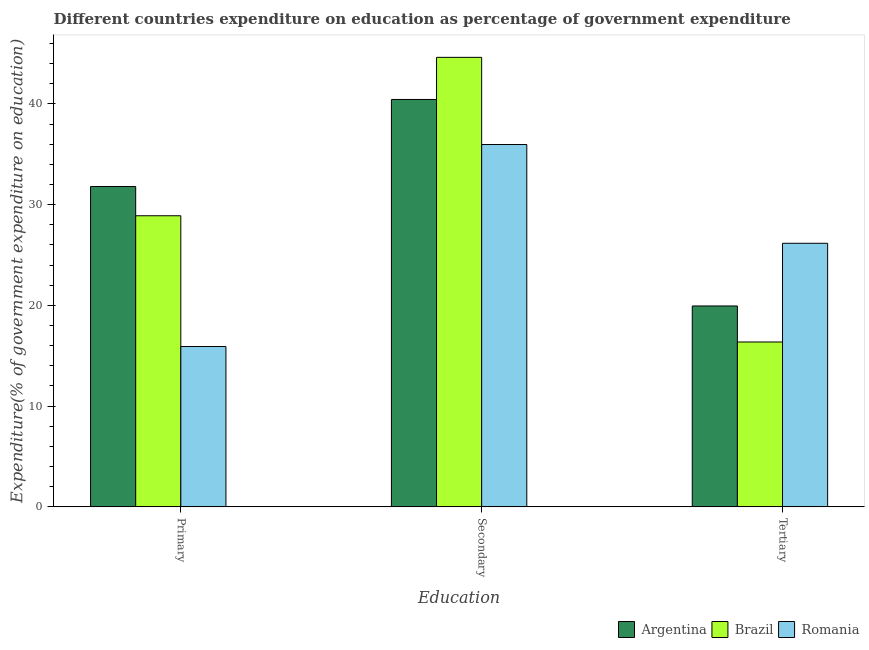How many different coloured bars are there?
Offer a very short reply. 3. How many groups of bars are there?
Ensure brevity in your answer.  3. Are the number of bars on each tick of the X-axis equal?
Your response must be concise. Yes. How many bars are there on the 2nd tick from the left?
Make the answer very short. 3. What is the label of the 1st group of bars from the left?
Ensure brevity in your answer.  Primary. What is the expenditure on tertiary education in Argentina?
Ensure brevity in your answer.  19.94. Across all countries, what is the maximum expenditure on tertiary education?
Give a very brief answer. 26.16. Across all countries, what is the minimum expenditure on tertiary education?
Ensure brevity in your answer.  16.37. In which country was the expenditure on tertiary education maximum?
Offer a very short reply. Romania. In which country was the expenditure on tertiary education minimum?
Provide a short and direct response. Brazil. What is the total expenditure on primary education in the graph?
Your answer should be compact. 76.61. What is the difference between the expenditure on primary education in Brazil and that in Romania?
Provide a short and direct response. 12.98. What is the difference between the expenditure on primary education in Brazil and the expenditure on secondary education in Romania?
Your answer should be compact. -7.07. What is the average expenditure on secondary education per country?
Your answer should be compact. 40.34. What is the difference between the expenditure on primary education and expenditure on tertiary education in Romania?
Keep it short and to the point. -10.25. In how many countries, is the expenditure on primary education greater than 2 %?
Your answer should be very brief. 3. What is the ratio of the expenditure on tertiary education in Brazil to that in Romania?
Your response must be concise. 0.63. What is the difference between the highest and the second highest expenditure on primary education?
Offer a very short reply. 2.9. What is the difference between the highest and the lowest expenditure on primary education?
Your answer should be compact. 15.88. In how many countries, is the expenditure on primary education greater than the average expenditure on primary education taken over all countries?
Ensure brevity in your answer.  2. What does the 1st bar from the left in Tertiary represents?
Provide a succinct answer. Argentina. What does the 1st bar from the right in Primary represents?
Your answer should be very brief. Romania. Is it the case that in every country, the sum of the expenditure on primary education and expenditure on secondary education is greater than the expenditure on tertiary education?
Provide a succinct answer. Yes. How many bars are there?
Your response must be concise. 9. Are all the bars in the graph horizontal?
Your answer should be compact. No. How many countries are there in the graph?
Make the answer very short. 3. What is the difference between two consecutive major ticks on the Y-axis?
Offer a very short reply. 10. Are the values on the major ticks of Y-axis written in scientific E-notation?
Your response must be concise. No. Does the graph contain grids?
Provide a short and direct response. No. How are the legend labels stacked?
Offer a terse response. Horizontal. What is the title of the graph?
Your response must be concise. Different countries expenditure on education as percentage of government expenditure. What is the label or title of the X-axis?
Provide a succinct answer. Education. What is the label or title of the Y-axis?
Make the answer very short. Expenditure(% of government expenditure on education). What is the Expenditure(% of government expenditure on education) of Argentina in Primary?
Your answer should be very brief. 31.8. What is the Expenditure(% of government expenditure on education) in Brazil in Primary?
Give a very brief answer. 28.89. What is the Expenditure(% of government expenditure on education) in Romania in Primary?
Keep it short and to the point. 15.92. What is the Expenditure(% of government expenditure on education) in Argentina in Secondary?
Provide a short and direct response. 40.44. What is the Expenditure(% of government expenditure on education) of Brazil in Secondary?
Your answer should be very brief. 44.62. What is the Expenditure(% of government expenditure on education) in Romania in Secondary?
Your answer should be very brief. 35.97. What is the Expenditure(% of government expenditure on education) in Argentina in Tertiary?
Your answer should be compact. 19.94. What is the Expenditure(% of government expenditure on education) in Brazil in Tertiary?
Make the answer very short. 16.37. What is the Expenditure(% of government expenditure on education) of Romania in Tertiary?
Provide a short and direct response. 26.16. Across all Education, what is the maximum Expenditure(% of government expenditure on education) of Argentina?
Your response must be concise. 40.44. Across all Education, what is the maximum Expenditure(% of government expenditure on education) of Brazil?
Ensure brevity in your answer.  44.62. Across all Education, what is the maximum Expenditure(% of government expenditure on education) of Romania?
Ensure brevity in your answer.  35.97. Across all Education, what is the minimum Expenditure(% of government expenditure on education) in Argentina?
Keep it short and to the point. 19.94. Across all Education, what is the minimum Expenditure(% of government expenditure on education) of Brazil?
Provide a succinct answer. 16.37. Across all Education, what is the minimum Expenditure(% of government expenditure on education) of Romania?
Ensure brevity in your answer.  15.92. What is the total Expenditure(% of government expenditure on education) in Argentina in the graph?
Your answer should be very brief. 92.18. What is the total Expenditure(% of government expenditure on education) of Brazil in the graph?
Provide a short and direct response. 89.88. What is the total Expenditure(% of government expenditure on education) in Romania in the graph?
Ensure brevity in your answer.  78.04. What is the difference between the Expenditure(% of government expenditure on education) of Argentina in Primary and that in Secondary?
Your answer should be very brief. -8.64. What is the difference between the Expenditure(% of government expenditure on education) of Brazil in Primary and that in Secondary?
Keep it short and to the point. -15.72. What is the difference between the Expenditure(% of government expenditure on education) of Romania in Primary and that in Secondary?
Make the answer very short. -20.05. What is the difference between the Expenditure(% of government expenditure on education) in Argentina in Primary and that in Tertiary?
Provide a short and direct response. 11.86. What is the difference between the Expenditure(% of government expenditure on education) in Brazil in Primary and that in Tertiary?
Your answer should be compact. 12.53. What is the difference between the Expenditure(% of government expenditure on education) of Romania in Primary and that in Tertiary?
Provide a succinct answer. -10.25. What is the difference between the Expenditure(% of government expenditure on education) in Argentina in Secondary and that in Tertiary?
Your answer should be very brief. 20.5. What is the difference between the Expenditure(% of government expenditure on education) of Brazil in Secondary and that in Tertiary?
Your answer should be very brief. 28.25. What is the difference between the Expenditure(% of government expenditure on education) in Romania in Secondary and that in Tertiary?
Your answer should be very brief. 9.8. What is the difference between the Expenditure(% of government expenditure on education) of Argentina in Primary and the Expenditure(% of government expenditure on education) of Brazil in Secondary?
Your answer should be very brief. -12.82. What is the difference between the Expenditure(% of government expenditure on education) in Argentina in Primary and the Expenditure(% of government expenditure on education) in Romania in Secondary?
Offer a very short reply. -4.17. What is the difference between the Expenditure(% of government expenditure on education) in Brazil in Primary and the Expenditure(% of government expenditure on education) in Romania in Secondary?
Your response must be concise. -7.07. What is the difference between the Expenditure(% of government expenditure on education) of Argentina in Primary and the Expenditure(% of government expenditure on education) of Brazil in Tertiary?
Offer a terse response. 15.43. What is the difference between the Expenditure(% of government expenditure on education) in Argentina in Primary and the Expenditure(% of government expenditure on education) in Romania in Tertiary?
Ensure brevity in your answer.  5.64. What is the difference between the Expenditure(% of government expenditure on education) in Brazil in Primary and the Expenditure(% of government expenditure on education) in Romania in Tertiary?
Offer a very short reply. 2.73. What is the difference between the Expenditure(% of government expenditure on education) in Argentina in Secondary and the Expenditure(% of government expenditure on education) in Brazil in Tertiary?
Your answer should be very brief. 24.07. What is the difference between the Expenditure(% of government expenditure on education) of Argentina in Secondary and the Expenditure(% of government expenditure on education) of Romania in Tertiary?
Offer a terse response. 14.28. What is the difference between the Expenditure(% of government expenditure on education) in Brazil in Secondary and the Expenditure(% of government expenditure on education) in Romania in Tertiary?
Make the answer very short. 18.46. What is the average Expenditure(% of government expenditure on education) of Argentina per Education?
Ensure brevity in your answer.  30.73. What is the average Expenditure(% of government expenditure on education) in Brazil per Education?
Offer a very short reply. 29.96. What is the average Expenditure(% of government expenditure on education) of Romania per Education?
Your answer should be very brief. 26.01. What is the difference between the Expenditure(% of government expenditure on education) of Argentina and Expenditure(% of government expenditure on education) of Brazil in Primary?
Your answer should be very brief. 2.9. What is the difference between the Expenditure(% of government expenditure on education) of Argentina and Expenditure(% of government expenditure on education) of Romania in Primary?
Offer a very short reply. 15.88. What is the difference between the Expenditure(% of government expenditure on education) in Brazil and Expenditure(% of government expenditure on education) in Romania in Primary?
Offer a very short reply. 12.98. What is the difference between the Expenditure(% of government expenditure on education) in Argentina and Expenditure(% of government expenditure on education) in Brazil in Secondary?
Offer a very short reply. -4.18. What is the difference between the Expenditure(% of government expenditure on education) in Argentina and Expenditure(% of government expenditure on education) in Romania in Secondary?
Your answer should be compact. 4.47. What is the difference between the Expenditure(% of government expenditure on education) in Brazil and Expenditure(% of government expenditure on education) in Romania in Secondary?
Your response must be concise. 8.65. What is the difference between the Expenditure(% of government expenditure on education) of Argentina and Expenditure(% of government expenditure on education) of Brazil in Tertiary?
Give a very brief answer. 3.58. What is the difference between the Expenditure(% of government expenditure on education) of Argentina and Expenditure(% of government expenditure on education) of Romania in Tertiary?
Make the answer very short. -6.22. What is the difference between the Expenditure(% of government expenditure on education) in Brazil and Expenditure(% of government expenditure on education) in Romania in Tertiary?
Your response must be concise. -9.8. What is the ratio of the Expenditure(% of government expenditure on education) in Argentina in Primary to that in Secondary?
Make the answer very short. 0.79. What is the ratio of the Expenditure(% of government expenditure on education) of Brazil in Primary to that in Secondary?
Ensure brevity in your answer.  0.65. What is the ratio of the Expenditure(% of government expenditure on education) of Romania in Primary to that in Secondary?
Ensure brevity in your answer.  0.44. What is the ratio of the Expenditure(% of government expenditure on education) of Argentina in Primary to that in Tertiary?
Your answer should be very brief. 1.59. What is the ratio of the Expenditure(% of government expenditure on education) in Brazil in Primary to that in Tertiary?
Your answer should be compact. 1.77. What is the ratio of the Expenditure(% of government expenditure on education) of Romania in Primary to that in Tertiary?
Your response must be concise. 0.61. What is the ratio of the Expenditure(% of government expenditure on education) of Argentina in Secondary to that in Tertiary?
Provide a short and direct response. 2.03. What is the ratio of the Expenditure(% of government expenditure on education) of Brazil in Secondary to that in Tertiary?
Keep it short and to the point. 2.73. What is the ratio of the Expenditure(% of government expenditure on education) in Romania in Secondary to that in Tertiary?
Offer a terse response. 1.37. What is the difference between the highest and the second highest Expenditure(% of government expenditure on education) in Argentina?
Your answer should be very brief. 8.64. What is the difference between the highest and the second highest Expenditure(% of government expenditure on education) in Brazil?
Ensure brevity in your answer.  15.72. What is the difference between the highest and the second highest Expenditure(% of government expenditure on education) in Romania?
Make the answer very short. 9.8. What is the difference between the highest and the lowest Expenditure(% of government expenditure on education) of Argentina?
Make the answer very short. 20.5. What is the difference between the highest and the lowest Expenditure(% of government expenditure on education) of Brazil?
Provide a short and direct response. 28.25. What is the difference between the highest and the lowest Expenditure(% of government expenditure on education) in Romania?
Offer a very short reply. 20.05. 